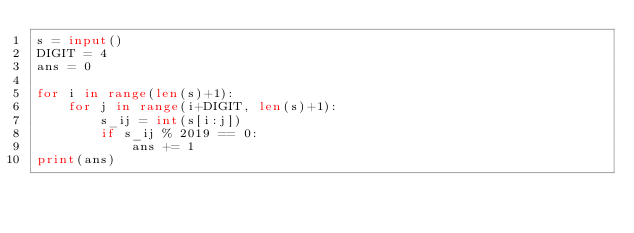Convert code to text. <code><loc_0><loc_0><loc_500><loc_500><_Python_>s = input()
DIGIT = 4
ans = 0

for i in range(len(s)+1):
    for j in range(i+DIGIT, len(s)+1):
        s_ij = int(s[i:j])
        if s_ij % 2019 == 0:
            ans += 1
print(ans)</code> 